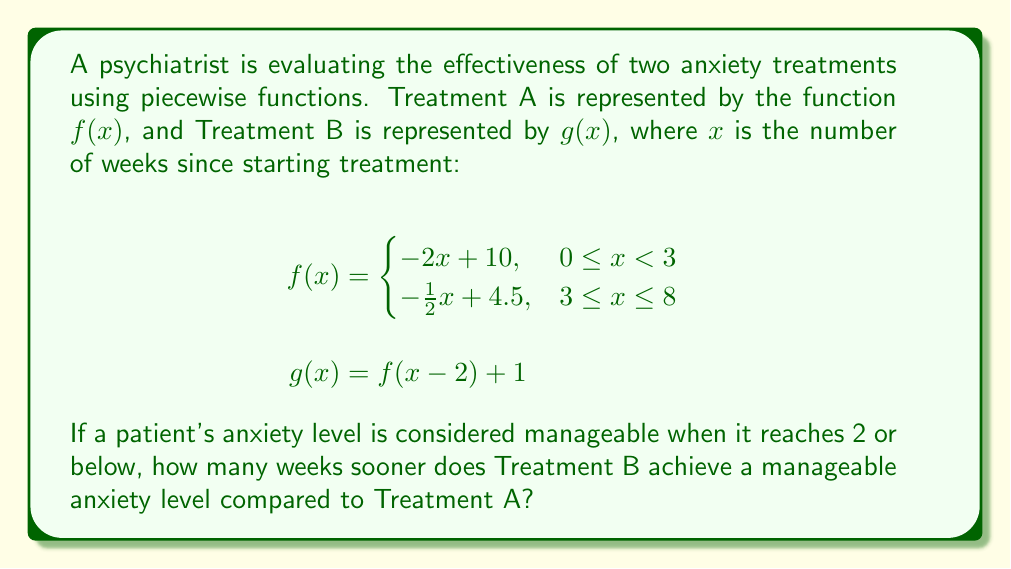What is the answer to this math problem? To solve this problem, we need to follow these steps:

1) First, let's understand what $g(x) = f(x-2) + 1$ means:
   - It's a horizontal shift of $f(x)$ 2 units to the right
   - It's a vertical shift of $f(x)$ 1 unit up

2) Now, let's find when $f(x)$ reaches 2:
   For the second piece of $f(x)$: $-\frac{1}{2}x + 4.5 = 2$
   $-\frac{1}{2}x = -2.5$
   $x = 5$ weeks

3) For $g(x)$, we need to solve:
   $f(x-2) + 1 = 2$
   $f(x-2) = 1$

4) This is equivalent to solving $f(y) = 1$ where $y = x-2$
   For the first piece of $f(y)$: $-2y + 10 = 1$
   $-2y = -9$
   $y = 4.5$

5) Since $y = x-2$, we have:
   $x-2 = 4.5$
   $x = 6.5$

6) However, at $x = 6.5$, we're in the second piece of $f(x)$. So we need to check:
   $-\frac{1}{2}(4.5) + 4.5 = 2.25$
   $2.25 + 1 = 3.25$

   This is still above 2, so we need to continue with the second piece.

7) Solving for the second piece:
   $-\frac{1}{2}(x-2) + 4.5 + 1 = 2$
   $-\frac{1}{2}x + 1 + 4.5 + 1 = 2$
   $-\frac{1}{2}x + 6.5 = 2$
   $-\frac{1}{2}x = -4.5$
   $x = 9$ weeks

8) The difference in time is:
   $9 - 5 = 4$ weeks
Answer: 4 weeks 